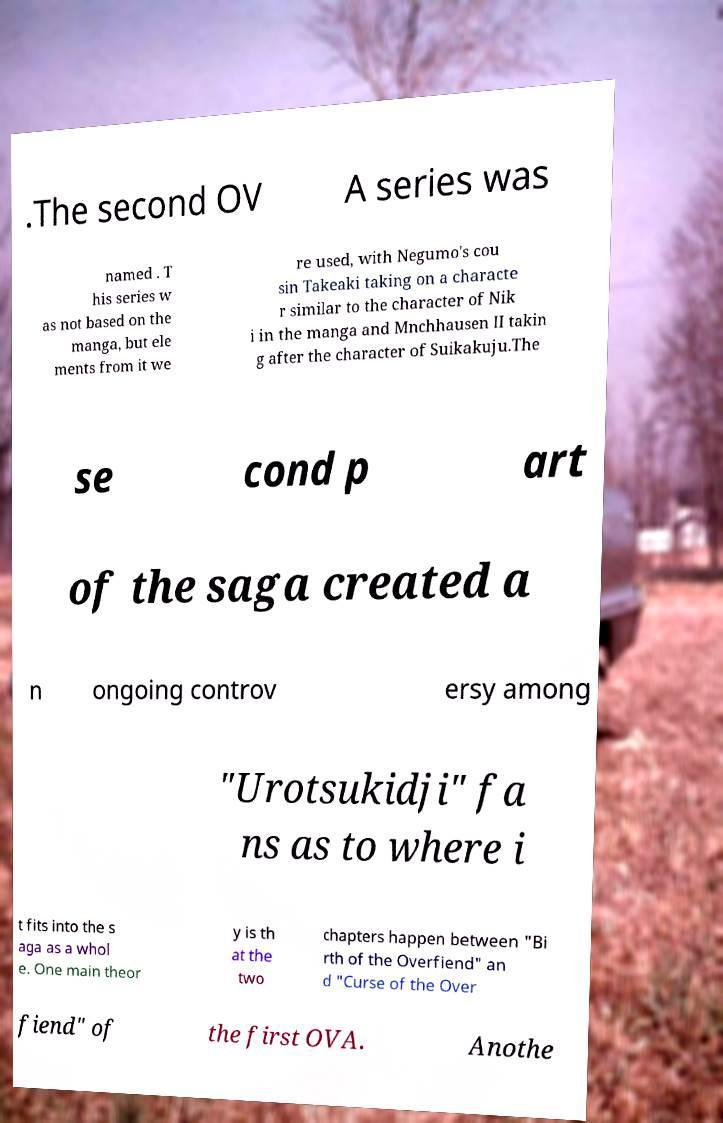I need the written content from this picture converted into text. Can you do that? .The second OV A series was named . T his series w as not based on the manga, but ele ments from it we re used, with Negumo's cou sin Takeaki taking on a characte r similar to the character of Nik i in the manga and Mnchhausen II takin g after the character of Suikakuju.The se cond p art of the saga created a n ongoing controv ersy among "Urotsukidji" fa ns as to where i t fits into the s aga as a whol e. One main theor y is th at the two chapters happen between "Bi rth of the Overfiend" an d "Curse of the Over fiend" of the first OVA. Anothe 